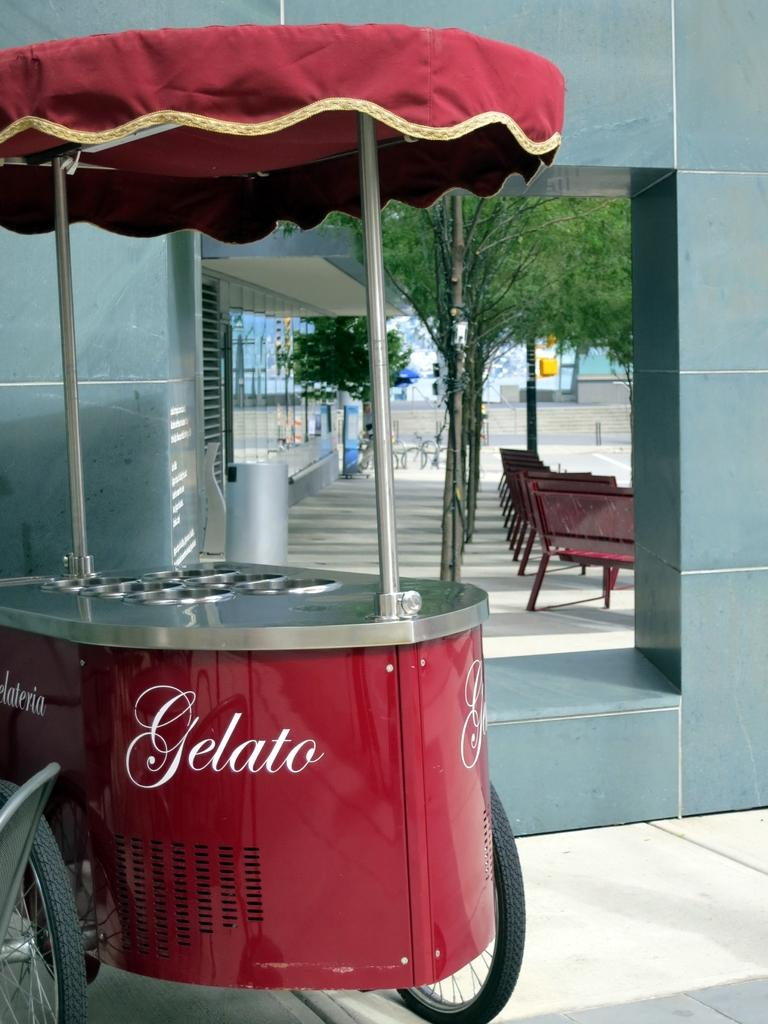What type of structure is present in the image? There is a stall in the image. What color is the stall? The stall is red in color. What can be seen in the background of the image? There are chairs, trees, and a glass building in the background of the image. What is the color of the trees in the image? The trees are green in color. Can you describe the building in the background? There is a glass building in the background of the image. What is the price of the decision made by the trees in the image? There is no decision made by the trees in the image, and therefore no price can be associated with it. 